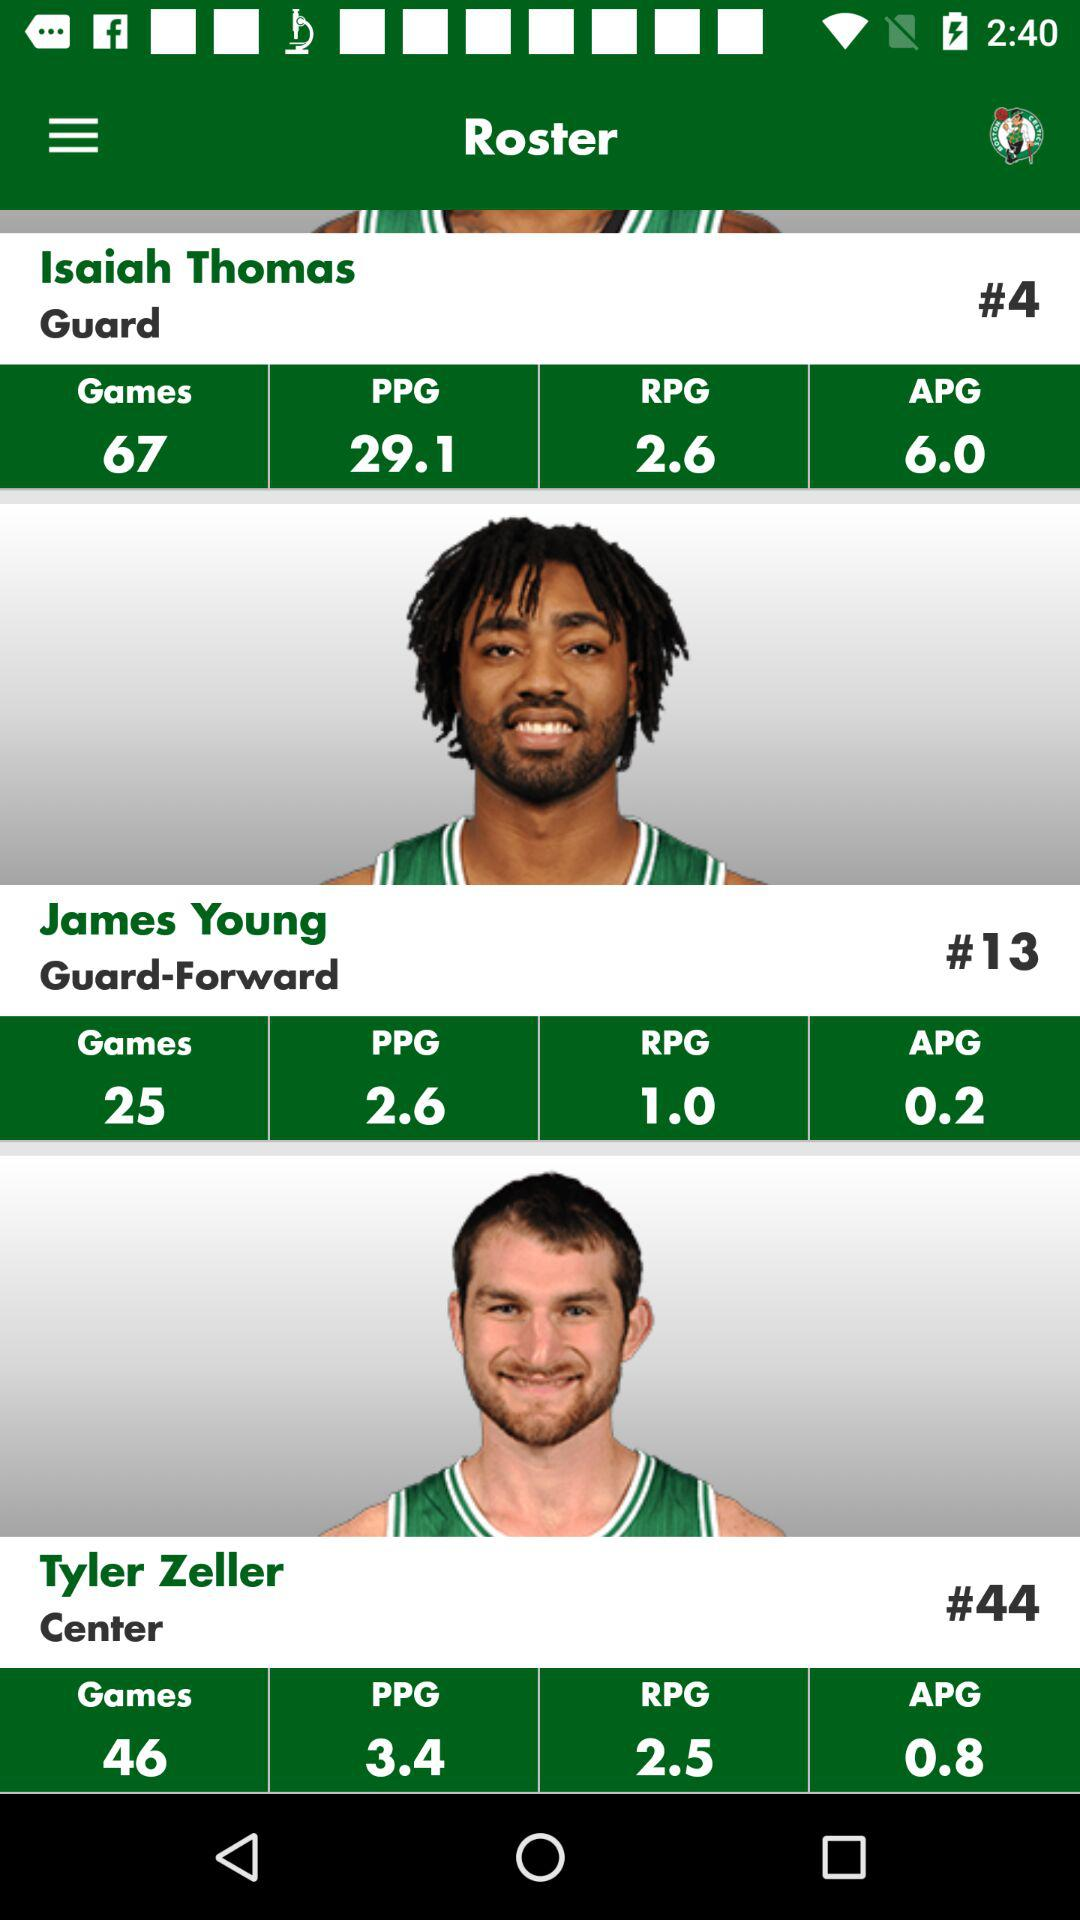How many more games did Isaiah Thomas play than James Young?
Answer the question using a single word or phrase. 42 